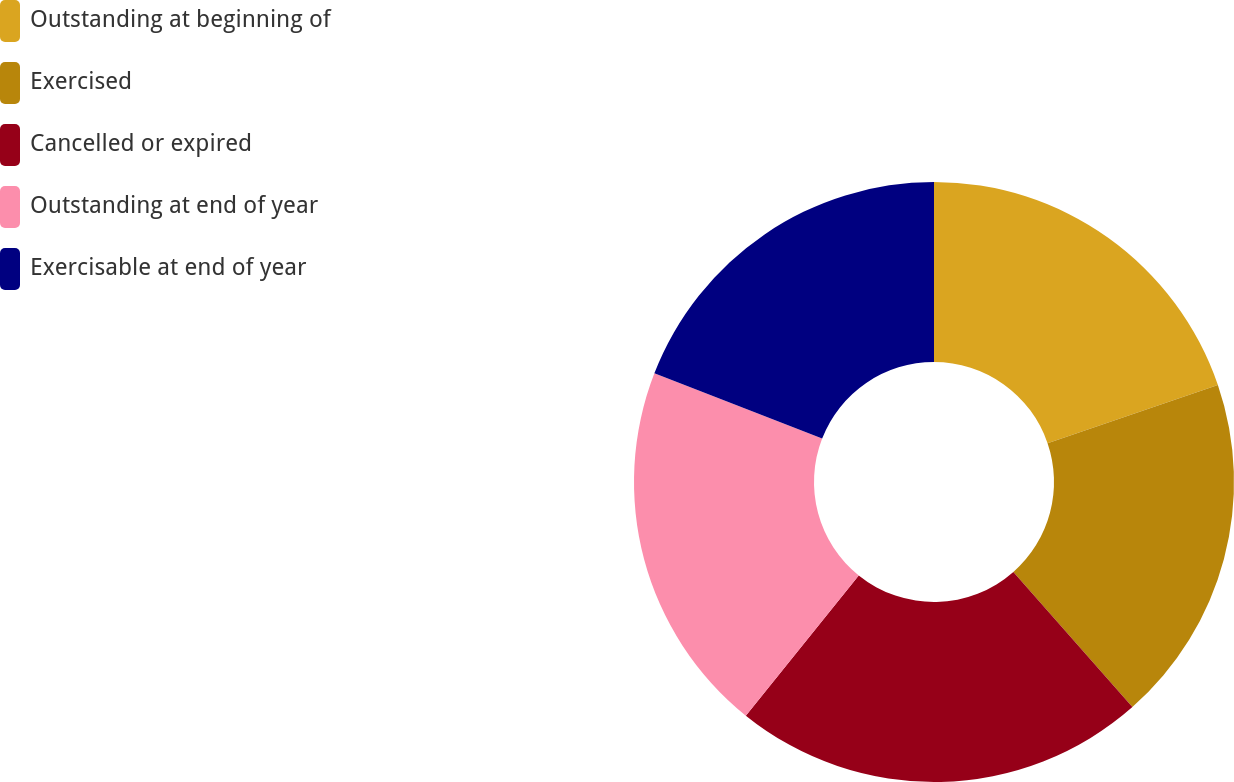<chart> <loc_0><loc_0><loc_500><loc_500><pie_chart><fcel>Outstanding at beginning of<fcel>Exercised<fcel>Cancelled or expired<fcel>Outstanding at end of year<fcel>Exercisable at end of year<nl><fcel>19.76%<fcel>18.74%<fcel>22.29%<fcel>20.11%<fcel>19.1%<nl></chart> 